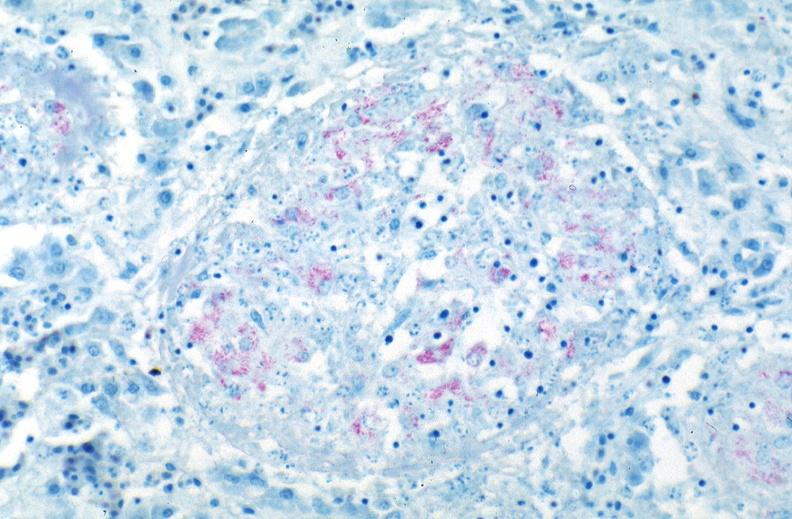s respiratory present?
Answer the question using a single word or phrase. Yes 